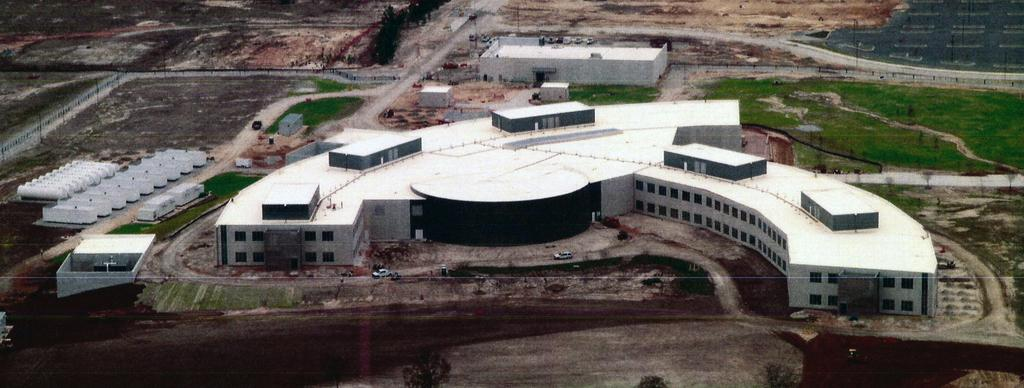What type of structures can be seen in the foreground of the image? There are buildings in the foreground of the image. What type of terrain is visible in the foreground of the image? There is land, grassland, and trees visible in the foreground of the image. Are there any man-made features in the foreground of the image? Yes, there are roads in the foreground of the image. How many cushions are placed on the son's bed in the image? There is no son or bed present in the image; it features buildings, land, grassland, trees, and roads in the foreground. What is the distribution of the trees in the image? The trees are located in the foreground of the image, but their distribution cannot be determined without more specific information about their arrangement. 